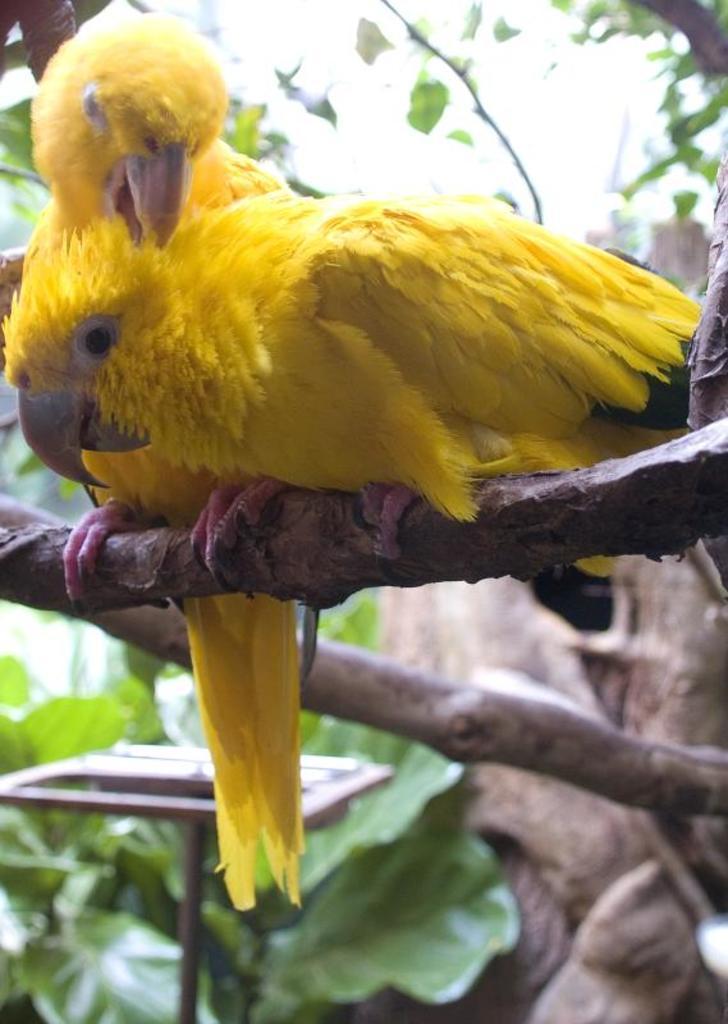Describe this image in one or two sentences. In this image there are two parrots on the branch of a tree. In the background of the image there are leafs and there is a metal stand. 